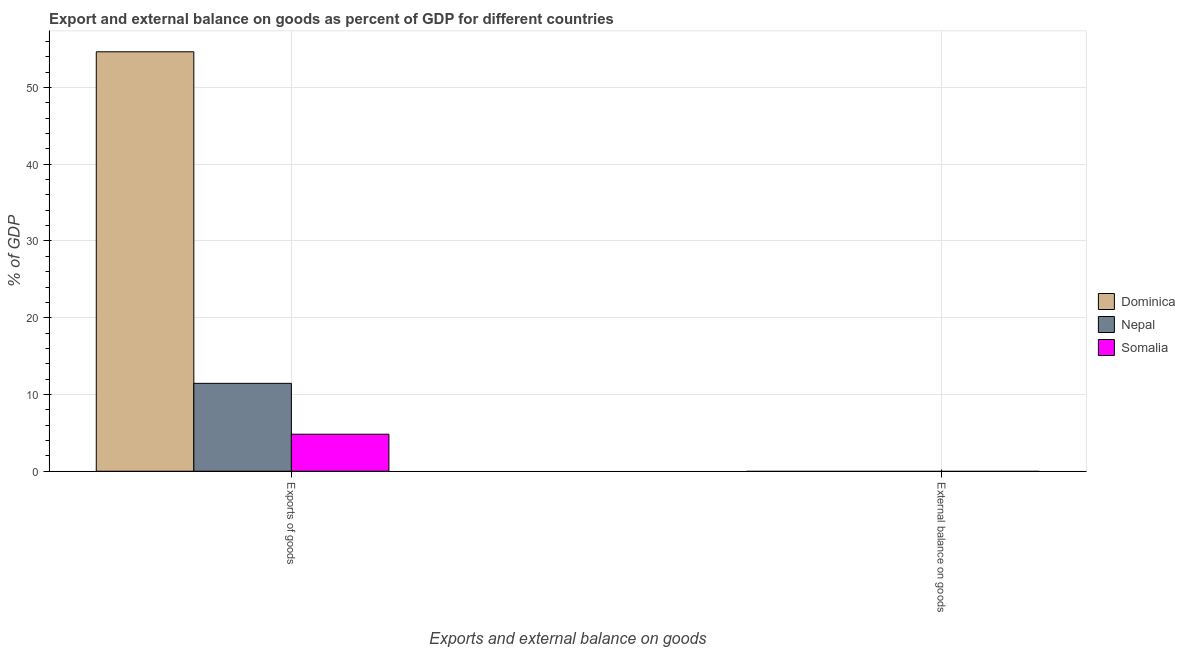How many bars are there on the 2nd tick from the right?
Provide a short and direct response. 3. What is the label of the 1st group of bars from the left?
Your response must be concise. Exports of goods. Across all countries, what is the maximum export of goods as percentage of gdp?
Provide a short and direct response. 54.64. Across all countries, what is the minimum external balance on goods as percentage of gdp?
Make the answer very short. 0. In which country was the export of goods as percentage of gdp maximum?
Provide a succinct answer. Dominica. What is the total export of goods as percentage of gdp in the graph?
Your answer should be very brief. 70.91. What is the difference between the export of goods as percentage of gdp in Somalia and that in Nepal?
Give a very brief answer. -6.62. What is the difference between the export of goods as percentage of gdp in Dominica and the external balance on goods as percentage of gdp in Somalia?
Your answer should be compact. 54.64. What is the average export of goods as percentage of gdp per country?
Make the answer very short. 23.64. In how many countries, is the export of goods as percentage of gdp greater than 46 %?
Ensure brevity in your answer.  1. What is the ratio of the export of goods as percentage of gdp in Somalia to that in Dominica?
Ensure brevity in your answer.  0.09. How many bars are there?
Your answer should be very brief. 3. How many countries are there in the graph?
Keep it short and to the point. 3. Are the values on the major ticks of Y-axis written in scientific E-notation?
Your answer should be very brief. No. Does the graph contain any zero values?
Your response must be concise. Yes. How many legend labels are there?
Offer a very short reply. 3. How are the legend labels stacked?
Provide a short and direct response. Vertical. What is the title of the graph?
Provide a short and direct response. Export and external balance on goods as percent of GDP for different countries. What is the label or title of the X-axis?
Your response must be concise. Exports and external balance on goods. What is the label or title of the Y-axis?
Ensure brevity in your answer.  % of GDP. What is the % of GDP of Dominica in Exports of goods?
Provide a succinct answer. 54.64. What is the % of GDP in Nepal in Exports of goods?
Your answer should be compact. 11.45. What is the % of GDP in Somalia in Exports of goods?
Give a very brief answer. 4.82. Across all Exports and external balance on goods, what is the maximum % of GDP in Dominica?
Your response must be concise. 54.64. Across all Exports and external balance on goods, what is the maximum % of GDP in Nepal?
Offer a very short reply. 11.45. Across all Exports and external balance on goods, what is the maximum % of GDP of Somalia?
Your answer should be very brief. 4.82. Across all Exports and external balance on goods, what is the minimum % of GDP of Dominica?
Provide a short and direct response. 0. Across all Exports and external balance on goods, what is the minimum % of GDP of Somalia?
Provide a succinct answer. 0. What is the total % of GDP in Dominica in the graph?
Give a very brief answer. 54.64. What is the total % of GDP of Nepal in the graph?
Ensure brevity in your answer.  11.45. What is the total % of GDP of Somalia in the graph?
Make the answer very short. 4.82. What is the average % of GDP in Dominica per Exports and external balance on goods?
Make the answer very short. 27.32. What is the average % of GDP of Nepal per Exports and external balance on goods?
Offer a terse response. 5.72. What is the average % of GDP in Somalia per Exports and external balance on goods?
Ensure brevity in your answer.  2.41. What is the difference between the % of GDP of Dominica and % of GDP of Nepal in Exports of goods?
Provide a succinct answer. 43.2. What is the difference between the % of GDP in Dominica and % of GDP in Somalia in Exports of goods?
Offer a terse response. 49.82. What is the difference between the % of GDP in Nepal and % of GDP in Somalia in Exports of goods?
Provide a succinct answer. 6.62. What is the difference between the highest and the lowest % of GDP of Dominica?
Make the answer very short. 54.64. What is the difference between the highest and the lowest % of GDP in Nepal?
Give a very brief answer. 11.45. What is the difference between the highest and the lowest % of GDP in Somalia?
Offer a terse response. 4.82. 